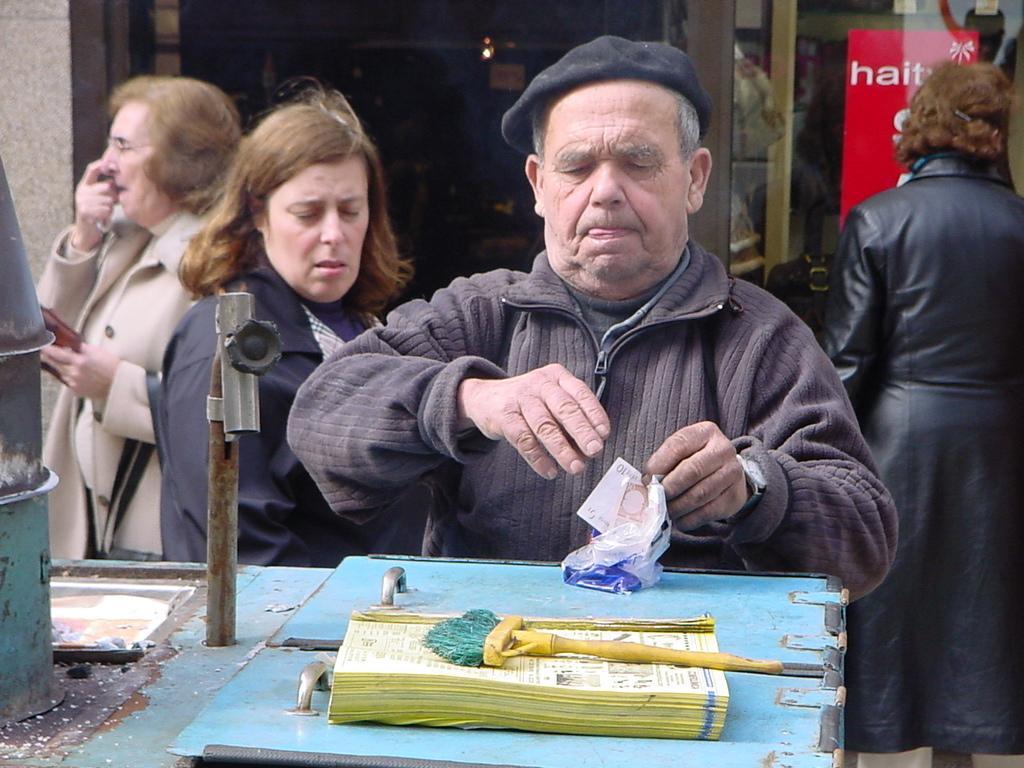How would you summarize this image in a sentence or two? This picture describes about group of people, in the middle of the image we can see a man, he wore a cap and he is holding a paper and a cover, in front of him we can see a metal rod, book and a brush. 